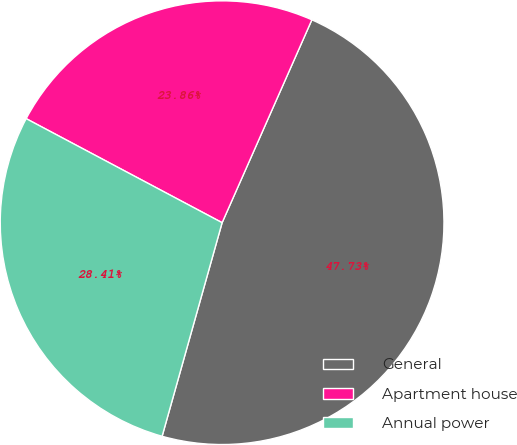Convert chart to OTSL. <chart><loc_0><loc_0><loc_500><loc_500><pie_chart><fcel>General<fcel>Apartment house<fcel>Annual power<nl><fcel>47.73%<fcel>23.86%<fcel>28.41%<nl></chart> 